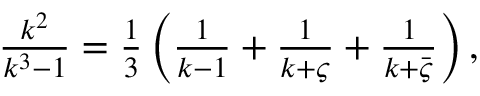Convert formula to latex. <formula><loc_0><loc_0><loc_500><loc_500>\begin{array} { r } { \frac { k ^ { 2 } } { k ^ { 3 } - 1 } = \frac { 1 } { 3 } \left ( \frac { 1 } { k - 1 } + \frac { 1 } { k + \varsigma } + \frac { 1 } { k + \bar { \varsigma } } \right ) , } \end{array}</formula> 